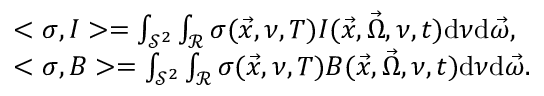<formula> <loc_0><loc_0><loc_500><loc_500>\begin{array} { r l } & { < \sigma , I > = \int _ { \mathcal { S } ^ { 2 } } \int _ { \mathcal { R } } \sigma ( \vec { x } , \nu , T ) I ( \vec { x } , \vec { \Omega } , \nu , t ) d \nu d \vec { \omega } , } \\ & { < \sigma , B > = \int _ { \mathcal { S } ^ { 2 } } \int _ { \mathcal { R } } \sigma ( \vec { x } , \nu , T ) B ( \vec { x } , \vec { \Omega } , \nu , t ) d \nu d \vec { \omega } . } \end{array}</formula> 